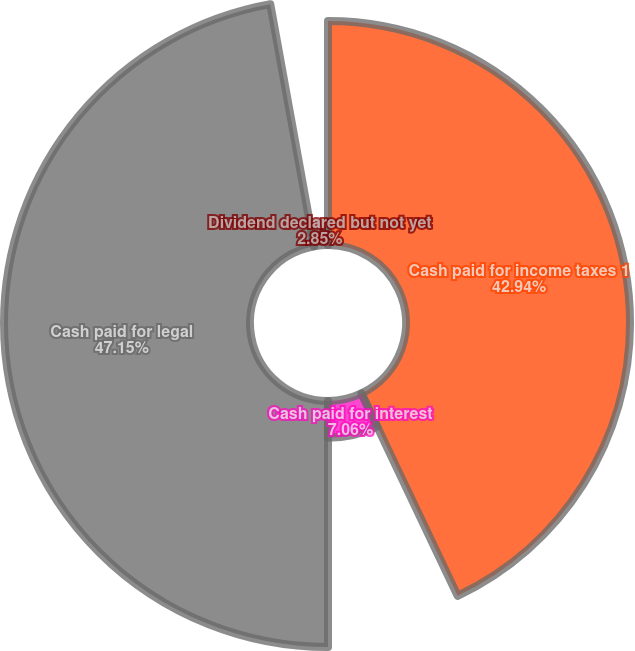Convert chart. <chart><loc_0><loc_0><loc_500><loc_500><pie_chart><fcel>Cash paid for income taxes 1<fcel>Cash paid for interest<fcel>Cash paid for legal<fcel>Dividend declared but not yet<nl><fcel>42.94%<fcel>7.06%<fcel>47.15%<fcel>2.85%<nl></chart> 